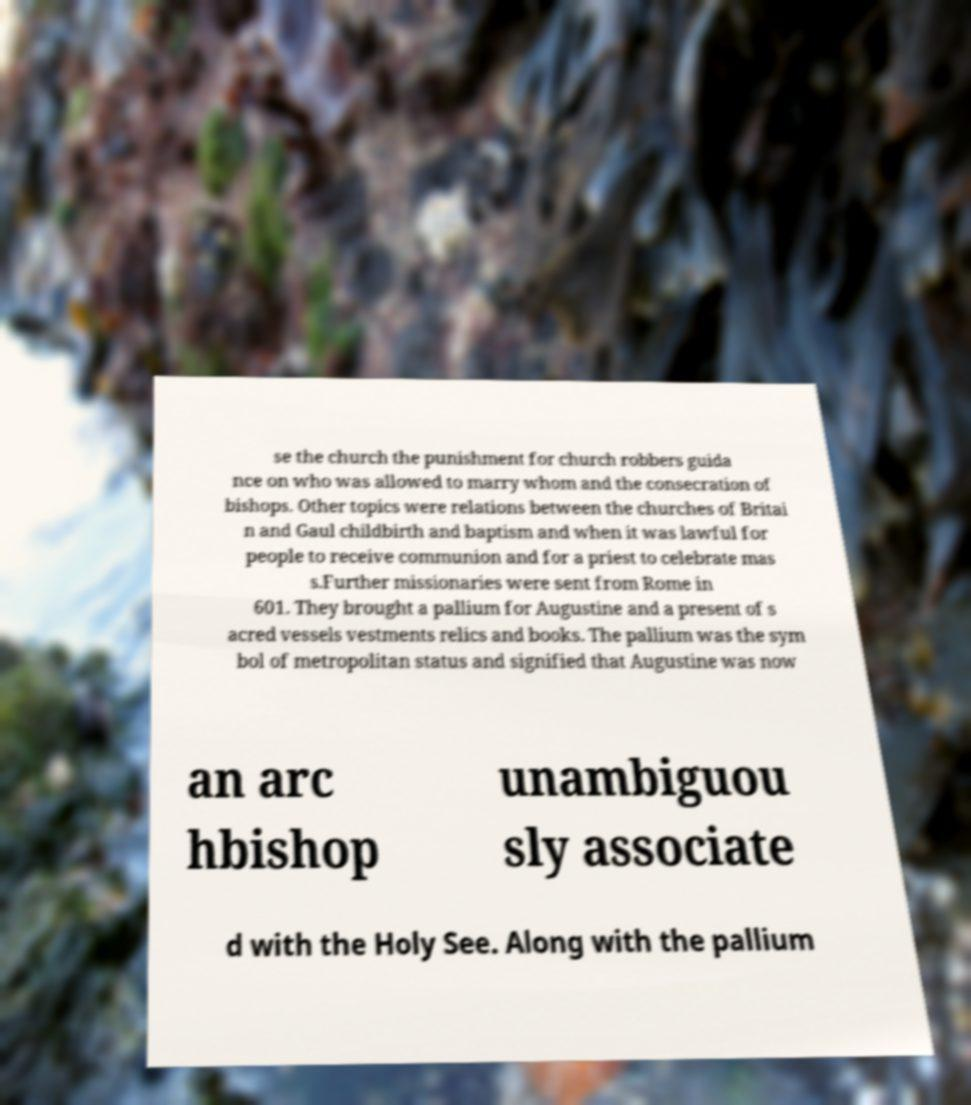There's text embedded in this image that I need extracted. Can you transcribe it verbatim? se the church the punishment for church robbers guida nce on who was allowed to marry whom and the consecration of bishops. Other topics were relations between the churches of Britai n and Gaul childbirth and baptism and when it was lawful for people to receive communion and for a priest to celebrate mas s.Further missionaries were sent from Rome in 601. They brought a pallium for Augustine and a present of s acred vessels vestments relics and books. The pallium was the sym bol of metropolitan status and signified that Augustine was now an arc hbishop unambiguou sly associate d with the Holy See. Along with the pallium 